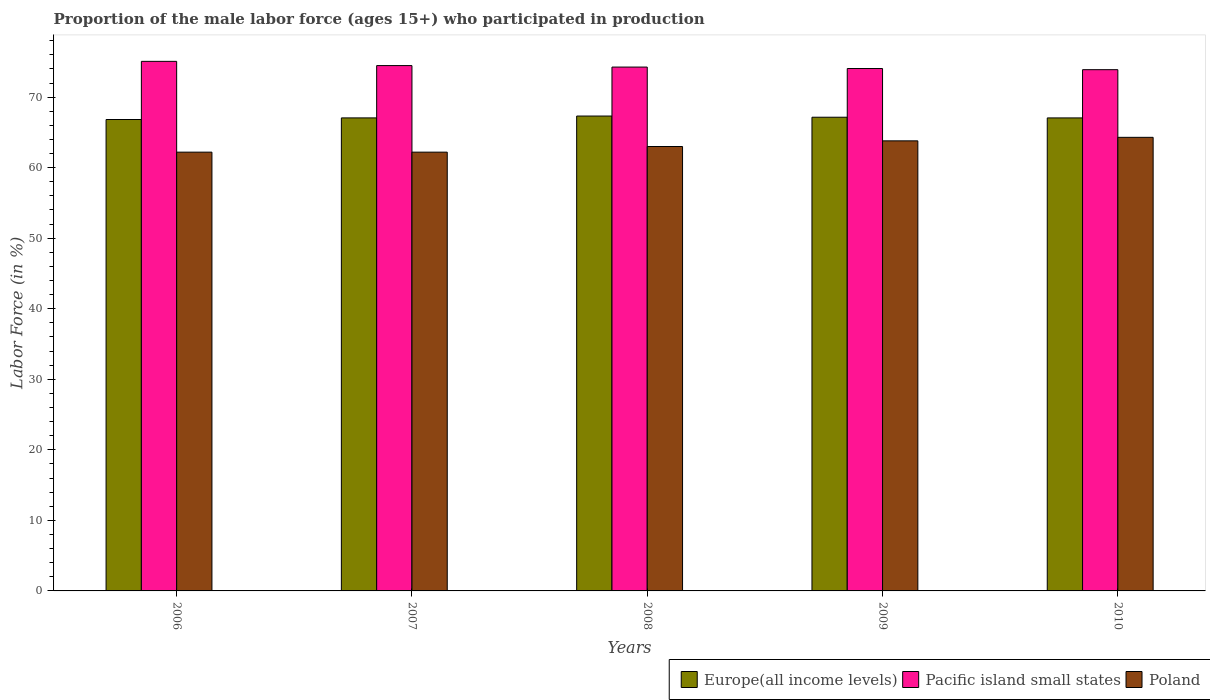How many groups of bars are there?
Your answer should be very brief. 5. Are the number of bars per tick equal to the number of legend labels?
Offer a very short reply. Yes. Are the number of bars on each tick of the X-axis equal?
Keep it short and to the point. Yes. How many bars are there on the 1st tick from the right?
Provide a succinct answer. 3. What is the label of the 4th group of bars from the left?
Make the answer very short. 2009. What is the proportion of the male labor force who participated in production in Poland in 2010?
Offer a terse response. 64.3. Across all years, what is the maximum proportion of the male labor force who participated in production in Poland?
Your response must be concise. 64.3. Across all years, what is the minimum proportion of the male labor force who participated in production in Poland?
Your answer should be very brief. 62.2. In which year was the proportion of the male labor force who participated in production in Poland minimum?
Make the answer very short. 2006. What is the total proportion of the male labor force who participated in production in Pacific island small states in the graph?
Provide a succinct answer. 371.75. What is the difference between the proportion of the male labor force who participated in production in Pacific island small states in 2006 and that in 2010?
Make the answer very short. 1.18. What is the difference between the proportion of the male labor force who participated in production in Pacific island small states in 2008 and the proportion of the male labor force who participated in production in Europe(all income levels) in 2009?
Offer a very short reply. 7.11. What is the average proportion of the male labor force who participated in production in Pacific island small states per year?
Give a very brief answer. 74.35. In the year 2010, what is the difference between the proportion of the male labor force who participated in production in Poland and proportion of the male labor force who participated in production in Europe(all income levels)?
Your answer should be compact. -2.75. In how many years, is the proportion of the male labor force who participated in production in Europe(all income levels) greater than 4 %?
Provide a short and direct response. 5. What is the ratio of the proportion of the male labor force who participated in production in Pacific island small states in 2007 to that in 2010?
Your answer should be very brief. 1.01. Is the proportion of the male labor force who participated in production in Europe(all income levels) in 2007 less than that in 2008?
Ensure brevity in your answer.  Yes. Is the difference between the proportion of the male labor force who participated in production in Poland in 2007 and 2010 greater than the difference between the proportion of the male labor force who participated in production in Europe(all income levels) in 2007 and 2010?
Provide a short and direct response. No. What is the difference between the highest and the second highest proportion of the male labor force who participated in production in Pacific island small states?
Offer a terse response. 0.6. What is the difference between the highest and the lowest proportion of the male labor force who participated in production in Europe(all income levels)?
Your response must be concise. 0.49. What does the 3rd bar from the left in 2007 represents?
Make the answer very short. Poland. What does the 1st bar from the right in 2010 represents?
Your answer should be very brief. Poland. Is it the case that in every year, the sum of the proportion of the male labor force who participated in production in Poland and proportion of the male labor force who participated in production in Pacific island small states is greater than the proportion of the male labor force who participated in production in Europe(all income levels)?
Provide a succinct answer. Yes. How many bars are there?
Offer a terse response. 15. Are all the bars in the graph horizontal?
Ensure brevity in your answer.  No. How many years are there in the graph?
Ensure brevity in your answer.  5. What is the difference between two consecutive major ticks on the Y-axis?
Ensure brevity in your answer.  10. Are the values on the major ticks of Y-axis written in scientific E-notation?
Keep it short and to the point. No. Where does the legend appear in the graph?
Your answer should be compact. Bottom right. What is the title of the graph?
Provide a succinct answer. Proportion of the male labor force (ages 15+) who participated in production. What is the label or title of the X-axis?
Your response must be concise. Years. What is the label or title of the Y-axis?
Offer a very short reply. Labor Force (in %). What is the Labor Force (in %) of Europe(all income levels) in 2006?
Give a very brief answer. 66.83. What is the Labor Force (in %) of Pacific island small states in 2006?
Keep it short and to the point. 75.07. What is the Labor Force (in %) in Poland in 2006?
Your response must be concise. 62.2. What is the Labor Force (in %) of Europe(all income levels) in 2007?
Your answer should be very brief. 67.05. What is the Labor Force (in %) of Pacific island small states in 2007?
Keep it short and to the point. 74.47. What is the Labor Force (in %) in Poland in 2007?
Offer a terse response. 62.2. What is the Labor Force (in %) of Europe(all income levels) in 2008?
Make the answer very short. 67.32. What is the Labor Force (in %) of Pacific island small states in 2008?
Ensure brevity in your answer.  74.26. What is the Labor Force (in %) of Europe(all income levels) in 2009?
Offer a very short reply. 67.15. What is the Labor Force (in %) of Pacific island small states in 2009?
Make the answer very short. 74.05. What is the Labor Force (in %) in Poland in 2009?
Keep it short and to the point. 63.8. What is the Labor Force (in %) of Europe(all income levels) in 2010?
Make the answer very short. 67.05. What is the Labor Force (in %) in Pacific island small states in 2010?
Make the answer very short. 73.89. What is the Labor Force (in %) of Poland in 2010?
Ensure brevity in your answer.  64.3. Across all years, what is the maximum Labor Force (in %) of Europe(all income levels)?
Provide a short and direct response. 67.32. Across all years, what is the maximum Labor Force (in %) in Pacific island small states?
Offer a terse response. 75.07. Across all years, what is the maximum Labor Force (in %) in Poland?
Give a very brief answer. 64.3. Across all years, what is the minimum Labor Force (in %) in Europe(all income levels)?
Offer a very short reply. 66.83. Across all years, what is the minimum Labor Force (in %) in Pacific island small states?
Your answer should be compact. 73.89. Across all years, what is the minimum Labor Force (in %) in Poland?
Offer a very short reply. 62.2. What is the total Labor Force (in %) in Europe(all income levels) in the graph?
Make the answer very short. 335.4. What is the total Labor Force (in %) in Pacific island small states in the graph?
Make the answer very short. 371.75. What is the total Labor Force (in %) in Poland in the graph?
Keep it short and to the point. 315.5. What is the difference between the Labor Force (in %) in Europe(all income levels) in 2006 and that in 2007?
Make the answer very short. -0.23. What is the difference between the Labor Force (in %) in Pacific island small states in 2006 and that in 2007?
Provide a succinct answer. 0.6. What is the difference between the Labor Force (in %) in Europe(all income levels) in 2006 and that in 2008?
Make the answer very short. -0.49. What is the difference between the Labor Force (in %) in Pacific island small states in 2006 and that in 2008?
Your response must be concise. 0.81. What is the difference between the Labor Force (in %) in Europe(all income levels) in 2006 and that in 2009?
Make the answer very short. -0.32. What is the difference between the Labor Force (in %) of Pacific island small states in 2006 and that in 2009?
Your answer should be compact. 1.02. What is the difference between the Labor Force (in %) of Europe(all income levels) in 2006 and that in 2010?
Make the answer very short. -0.23. What is the difference between the Labor Force (in %) in Pacific island small states in 2006 and that in 2010?
Ensure brevity in your answer.  1.18. What is the difference between the Labor Force (in %) in Europe(all income levels) in 2007 and that in 2008?
Offer a very short reply. -0.26. What is the difference between the Labor Force (in %) in Pacific island small states in 2007 and that in 2008?
Your answer should be compact. 0.21. What is the difference between the Labor Force (in %) of Europe(all income levels) in 2007 and that in 2009?
Your response must be concise. -0.1. What is the difference between the Labor Force (in %) of Pacific island small states in 2007 and that in 2009?
Offer a very short reply. 0.42. What is the difference between the Labor Force (in %) in Europe(all income levels) in 2007 and that in 2010?
Provide a short and direct response. 0. What is the difference between the Labor Force (in %) in Pacific island small states in 2007 and that in 2010?
Keep it short and to the point. 0.58. What is the difference between the Labor Force (in %) of Poland in 2007 and that in 2010?
Keep it short and to the point. -2.1. What is the difference between the Labor Force (in %) of Europe(all income levels) in 2008 and that in 2009?
Keep it short and to the point. 0.17. What is the difference between the Labor Force (in %) in Pacific island small states in 2008 and that in 2009?
Make the answer very short. 0.21. What is the difference between the Labor Force (in %) in Poland in 2008 and that in 2009?
Provide a succinct answer. -0.8. What is the difference between the Labor Force (in %) of Europe(all income levels) in 2008 and that in 2010?
Ensure brevity in your answer.  0.26. What is the difference between the Labor Force (in %) of Pacific island small states in 2008 and that in 2010?
Offer a terse response. 0.37. What is the difference between the Labor Force (in %) of Europe(all income levels) in 2009 and that in 2010?
Offer a very short reply. 0.1. What is the difference between the Labor Force (in %) in Pacific island small states in 2009 and that in 2010?
Keep it short and to the point. 0.16. What is the difference between the Labor Force (in %) in Poland in 2009 and that in 2010?
Your response must be concise. -0.5. What is the difference between the Labor Force (in %) of Europe(all income levels) in 2006 and the Labor Force (in %) of Pacific island small states in 2007?
Your answer should be very brief. -7.64. What is the difference between the Labor Force (in %) of Europe(all income levels) in 2006 and the Labor Force (in %) of Poland in 2007?
Ensure brevity in your answer.  4.63. What is the difference between the Labor Force (in %) in Pacific island small states in 2006 and the Labor Force (in %) in Poland in 2007?
Your answer should be very brief. 12.87. What is the difference between the Labor Force (in %) of Europe(all income levels) in 2006 and the Labor Force (in %) of Pacific island small states in 2008?
Keep it short and to the point. -7.43. What is the difference between the Labor Force (in %) of Europe(all income levels) in 2006 and the Labor Force (in %) of Poland in 2008?
Offer a terse response. 3.83. What is the difference between the Labor Force (in %) in Pacific island small states in 2006 and the Labor Force (in %) in Poland in 2008?
Ensure brevity in your answer.  12.07. What is the difference between the Labor Force (in %) in Europe(all income levels) in 2006 and the Labor Force (in %) in Pacific island small states in 2009?
Ensure brevity in your answer.  -7.23. What is the difference between the Labor Force (in %) in Europe(all income levels) in 2006 and the Labor Force (in %) in Poland in 2009?
Your answer should be very brief. 3.03. What is the difference between the Labor Force (in %) in Pacific island small states in 2006 and the Labor Force (in %) in Poland in 2009?
Provide a short and direct response. 11.27. What is the difference between the Labor Force (in %) of Europe(all income levels) in 2006 and the Labor Force (in %) of Pacific island small states in 2010?
Ensure brevity in your answer.  -7.06. What is the difference between the Labor Force (in %) of Europe(all income levels) in 2006 and the Labor Force (in %) of Poland in 2010?
Offer a terse response. 2.53. What is the difference between the Labor Force (in %) in Pacific island small states in 2006 and the Labor Force (in %) in Poland in 2010?
Offer a very short reply. 10.77. What is the difference between the Labor Force (in %) in Europe(all income levels) in 2007 and the Labor Force (in %) in Pacific island small states in 2008?
Ensure brevity in your answer.  -7.21. What is the difference between the Labor Force (in %) in Europe(all income levels) in 2007 and the Labor Force (in %) in Poland in 2008?
Your response must be concise. 4.05. What is the difference between the Labor Force (in %) in Pacific island small states in 2007 and the Labor Force (in %) in Poland in 2008?
Provide a succinct answer. 11.47. What is the difference between the Labor Force (in %) of Europe(all income levels) in 2007 and the Labor Force (in %) of Pacific island small states in 2009?
Keep it short and to the point. -7. What is the difference between the Labor Force (in %) of Europe(all income levels) in 2007 and the Labor Force (in %) of Poland in 2009?
Offer a terse response. 3.25. What is the difference between the Labor Force (in %) of Pacific island small states in 2007 and the Labor Force (in %) of Poland in 2009?
Give a very brief answer. 10.67. What is the difference between the Labor Force (in %) of Europe(all income levels) in 2007 and the Labor Force (in %) of Pacific island small states in 2010?
Your answer should be very brief. -6.83. What is the difference between the Labor Force (in %) in Europe(all income levels) in 2007 and the Labor Force (in %) in Poland in 2010?
Make the answer very short. 2.75. What is the difference between the Labor Force (in %) in Pacific island small states in 2007 and the Labor Force (in %) in Poland in 2010?
Give a very brief answer. 10.17. What is the difference between the Labor Force (in %) of Europe(all income levels) in 2008 and the Labor Force (in %) of Pacific island small states in 2009?
Your response must be concise. -6.74. What is the difference between the Labor Force (in %) of Europe(all income levels) in 2008 and the Labor Force (in %) of Poland in 2009?
Keep it short and to the point. 3.52. What is the difference between the Labor Force (in %) in Pacific island small states in 2008 and the Labor Force (in %) in Poland in 2009?
Your answer should be very brief. 10.46. What is the difference between the Labor Force (in %) of Europe(all income levels) in 2008 and the Labor Force (in %) of Pacific island small states in 2010?
Keep it short and to the point. -6.57. What is the difference between the Labor Force (in %) of Europe(all income levels) in 2008 and the Labor Force (in %) of Poland in 2010?
Keep it short and to the point. 3.02. What is the difference between the Labor Force (in %) of Pacific island small states in 2008 and the Labor Force (in %) of Poland in 2010?
Give a very brief answer. 9.96. What is the difference between the Labor Force (in %) of Europe(all income levels) in 2009 and the Labor Force (in %) of Pacific island small states in 2010?
Make the answer very short. -6.74. What is the difference between the Labor Force (in %) in Europe(all income levels) in 2009 and the Labor Force (in %) in Poland in 2010?
Provide a short and direct response. 2.85. What is the difference between the Labor Force (in %) in Pacific island small states in 2009 and the Labor Force (in %) in Poland in 2010?
Ensure brevity in your answer.  9.75. What is the average Labor Force (in %) of Europe(all income levels) per year?
Your response must be concise. 67.08. What is the average Labor Force (in %) in Pacific island small states per year?
Your answer should be compact. 74.35. What is the average Labor Force (in %) in Poland per year?
Provide a short and direct response. 63.1. In the year 2006, what is the difference between the Labor Force (in %) in Europe(all income levels) and Labor Force (in %) in Pacific island small states?
Make the answer very short. -8.24. In the year 2006, what is the difference between the Labor Force (in %) in Europe(all income levels) and Labor Force (in %) in Poland?
Provide a succinct answer. 4.63. In the year 2006, what is the difference between the Labor Force (in %) of Pacific island small states and Labor Force (in %) of Poland?
Make the answer very short. 12.87. In the year 2007, what is the difference between the Labor Force (in %) of Europe(all income levels) and Labor Force (in %) of Pacific island small states?
Offer a very short reply. -7.42. In the year 2007, what is the difference between the Labor Force (in %) of Europe(all income levels) and Labor Force (in %) of Poland?
Your answer should be very brief. 4.85. In the year 2007, what is the difference between the Labor Force (in %) in Pacific island small states and Labor Force (in %) in Poland?
Offer a terse response. 12.27. In the year 2008, what is the difference between the Labor Force (in %) of Europe(all income levels) and Labor Force (in %) of Pacific island small states?
Make the answer very short. -6.94. In the year 2008, what is the difference between the Labor Force (in %) in Europe(all income levels) and Labor Force (in %) in Poland?
Keep it short and to the point. 4.32. In the year 2008, what is the difference between the Labor Force (in %) of Pacific island small states and Labor Force (in %) of Poland?
Offer a terse response. 11.26. In the year 2009, what is the difference between the Labor Force (in %) in Europe(all income levels) and Labor Force (in %) in Pacific island small states?
Make the answer very short. -6.9. In the year 2009, what is the difference between the Labor Force (in %) of Europe(all income levels) and Labor Force (in %) of Poland?
Your response must be concise. 3.35. In the year 2009, what is the difference between the Labor Force (in %) in Pacific island small states and Labor Force (in %) in Poland?
Ensure brevity in your answer.  10.25. In the year 2010, what is the difference between the Labor Force (in %) of Europe(all income levels) and Labor Force (in %) of Pacific island small states?
Keep it short and to the point. -6.84. In the year 2010, what is the difference between the Labor Force (in %) of Europe(all income levels) and Labor Force (in %) of Poland?
Keep it short and to the point. 2.75. In the year 2010, what is the difference between the Labor Force (in %) of Pacific island small states and Labor Force (in %) of Poland?
Keep it short and to the point. 9.59. What is the ratio of the Labor Force (in %) of Europe(all income levels) in 2006 to that in 2007?
Offer a terse response. 1. What is the ratio of the Labor Force (in %) of Europe(all income levels) in 2006 to that in 2008?
Your response must be concise. 0.99. What is the ratio of the Labor Force (in %) of Pacific island small states in 2006 to that in 2008?
Give a very brief answer. 1.01. What is the ratio of the Labor Force (in %) of Poland in 2006 to that in 2008?
Offer a very short reply. 0.99. What is the ratio of the Labor Force (in %) in Europe(all income levels) in 2006 to that in 2009?
Give a very brief answer. 1. What is the ratio of the Labor Force (in %) of Pacific island small states in 2006 to that in 2009?
Your answer should be very brief. 1.01. What is the ratio of the Labor Force (in %) in Poland in 2006 to that in 2009?
Give a very brief answer. 0.97. What is the ratio of the Labor Force (in %) of Europe(all income levels) in 2006 to that in 2010?
Ensure brevity in your answer.  1. What is the ratio of the Labor Force (in %) of Poland in 2006 to that in 2010?
Ensure brevity in your answer.  0.97. What is the ratio of the Labor Force (in %) of Europe(all income levels) in 2007 to that in 2008?
Keep it short and to the point. 1. What is the ratio of the Labor Force (in %) of Poland in 2007 to that in 2008?
Your answer should be very brief. 0.99. What is the ratio of the Labor Force (in %) of Europe(all income levels) in 2007 to that in 2009?
Keep it short and to the point. 1. What is the ratio of the Labor Force (in %) in Pacific island small states in 2007 to that in 2009?
Give a very brief answer. 1.01. What is the ratio of the Labor Force (in %) of Poland in 2007 to that in 2009?
Offer a terse response. 0.97. What is the ratio of the Labor Force (in %) of Europe(all income levels) in 2007 to that in 2010?
Provide a short and direct response. 1. What is the ratio of the Labor Force (in %) in Pacific island small states in 2007 to that in 2010?
Your answer should be compact. 1.01. What is the ratio of the Labor Force (in %) in Poland in 2007 to that in 2010?
Keep it short and to the point. 0.97. What is the ratio of the Labor Force (in %) in Europe(all income levels) in 2008 to that in 2009?
Offer a terse response. 1. What is the ratio of the Labor Force (in %) of Poland in 2008 to that in 2009?
Provide a succinct answer. 0.99. What is the ratio of the Labor Force (in %) in Poland in 2008 to that in 2010?
Give a very brief answer. 0.98. What is the ratio of the Labor Force (in %) of Europe(all income levels) in 2009 to that in 2010?
Your response must be concise. 1. What is the ratio of the Labor Force (in %) of Poland in 2009 to that in 2010?
Your response must be concise. 0.99. What is the difference between the highest and the second highest Labor Force (in %) in Europe(all income levels)?
Make the answer very short. 0.17. What is the difference between the highest and the second highest Labor Force (in %) in Pacific island small states?
Provide a short and direct response. 0.6. What is the difference between the highest and the second highest Labor Force (in %) in Poland?
Your answer should be very brief. 0.5. What is the difference between the highest and the lowest Labor Force (in %) of Europe(all income levels)?
Your answer should be compact. 0.49. What is the difference between the highest and the lowest Labor Force (in %) of Pacific island small states?
Offer a terse response. 1.18. What is the difference between the highest and the lowest Labor Force (in %) in Poland?
Offer a very short reply. 2.1. 